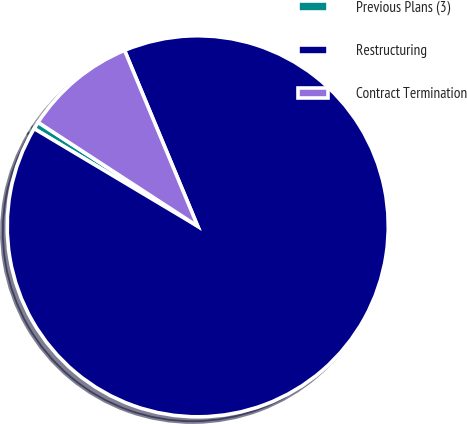Convert chart to OTSL. <chart><loc_0><loc_0><loc_500><loc_500><pie_chart><fcel>Previous Plans (3)<fcel>Restructuring<fcel>Contract Termination<nl><fcel>0.62%<fcel>89.83%<fcel>9.54%<nl></chart> 